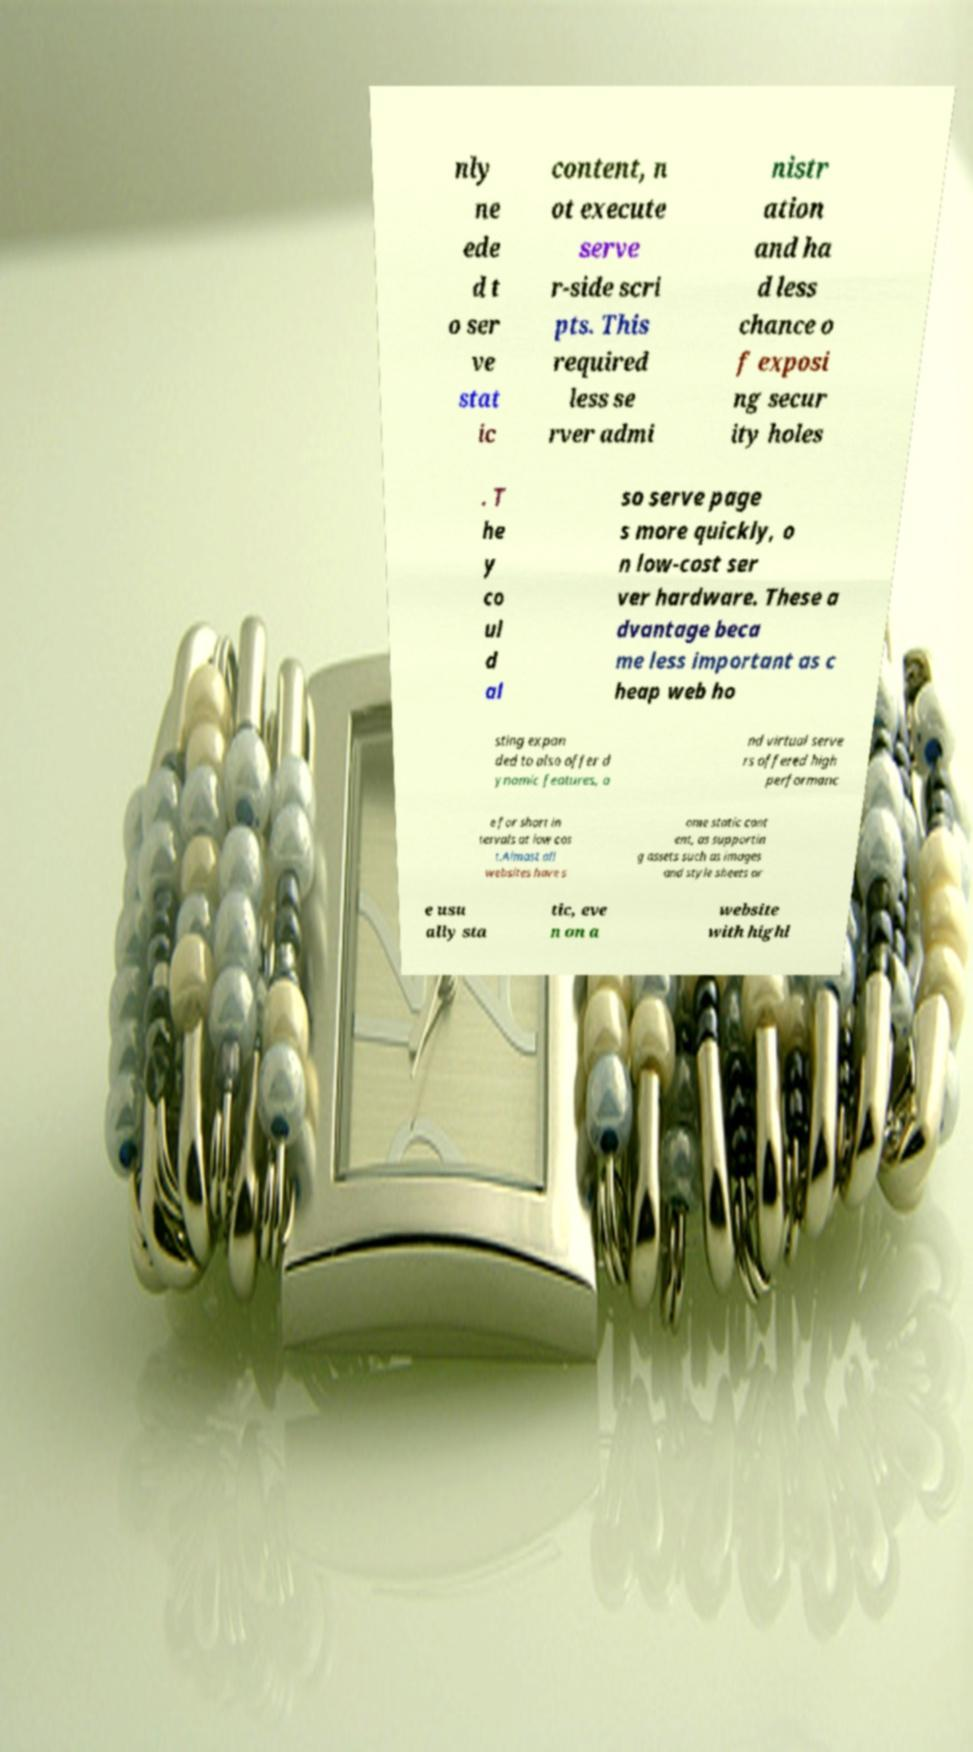There's text embedded in this image that I need extracted. Can you transcribe it verbatim? nly ne ede d t o ser ve stat ic content, n ot execute serve r-side scri pts. This required less se rver admi nistr ation and ha d less chance o f exposi ng secur ity holes . T he y co ul d al so serve page s more quickly, o n low-cost ser ver hardware. These a dvantage beca me less important as c heap web ho sting expan ded to also offer d ynamic features, a nd virtual serve rs offered high performanc e for short in tervals at low cos t.Almost all websites have s ome static cont ent, as supportin g assets such as images and style sheets ar e usu ally sta tic, eve n on a website with highl 